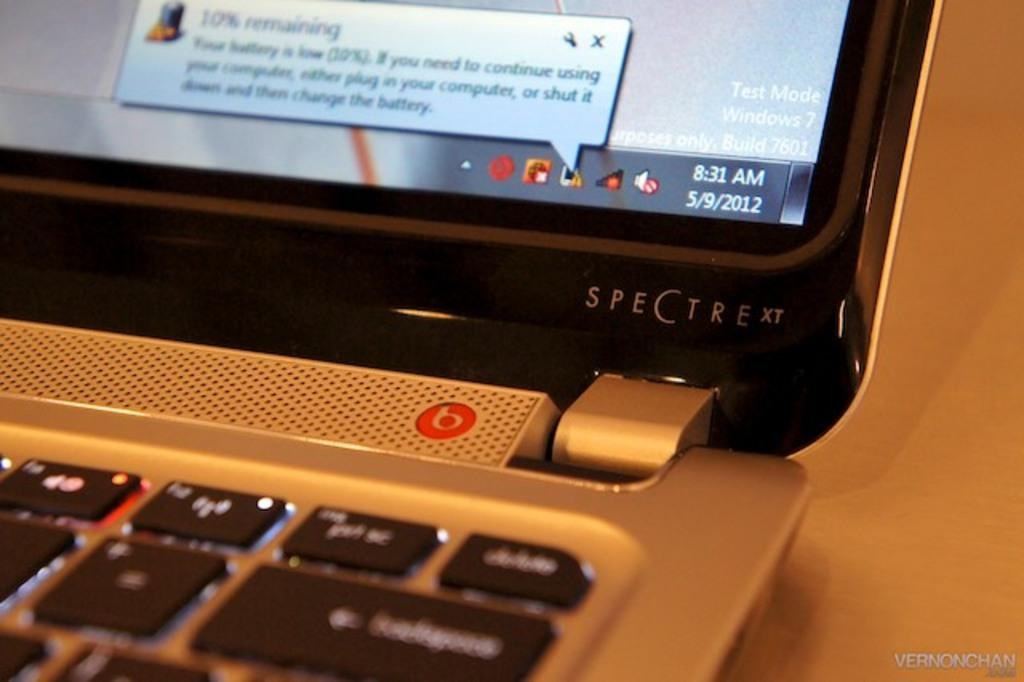Provide a one-sentence caption for the provided image. A Spectra xt computer is open and turned on. 